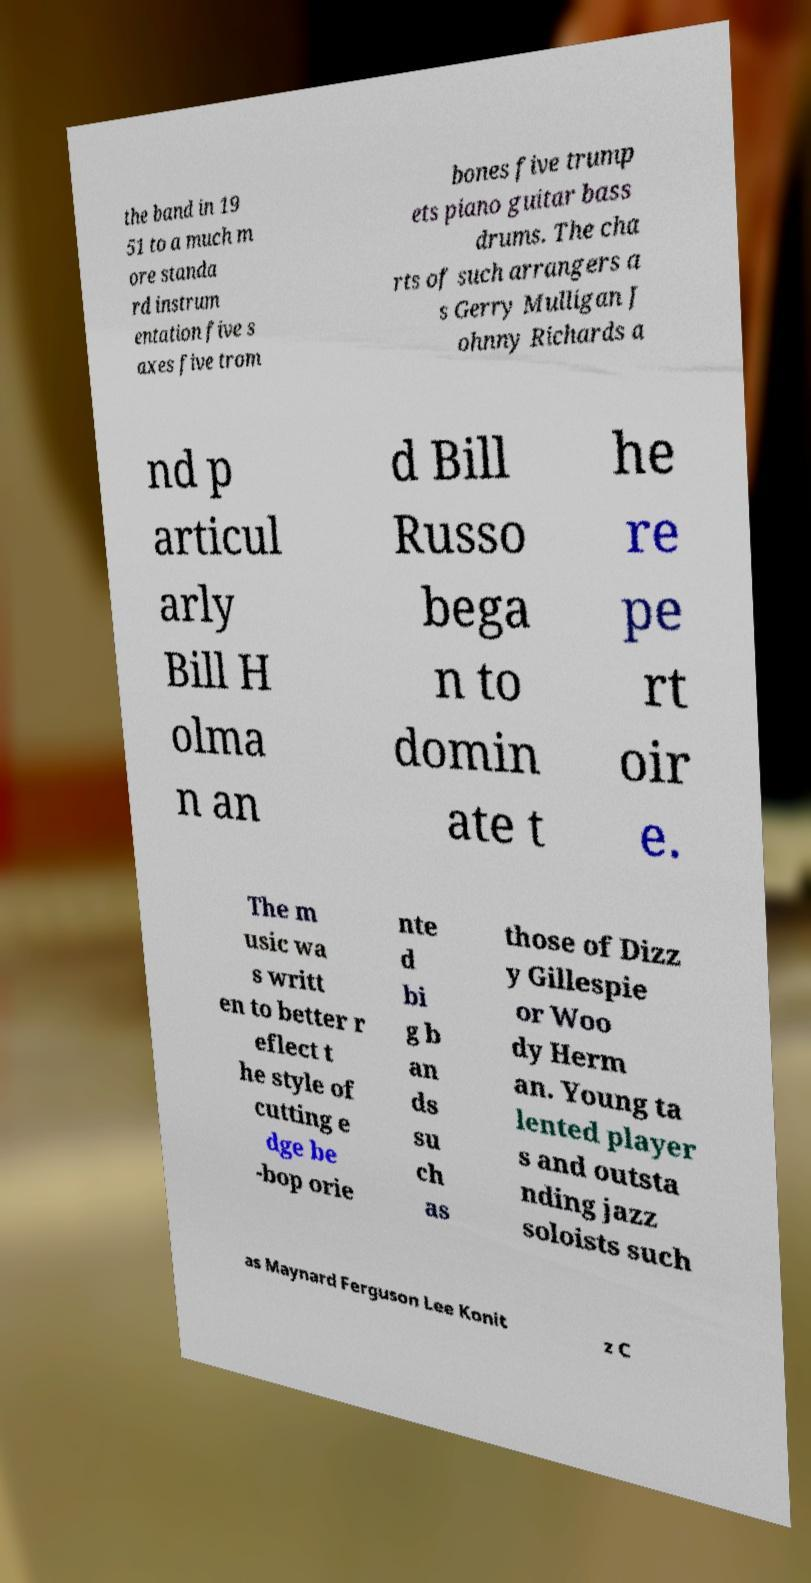For documentation purposes, I need the text within this image transcribed. Could you provide that? the band in 19 51 to a much m ore standa rd instrum entation five s axes five trom bones five trump ets piano guitar bass drums. The cha rts of such arrangers a s Gerry Mulligan J ohnny Richards a nd p articul arly Bill H olma n an d Bill Russo bega n to domin ate t he re pe rt oir e. The m usic wa s writt en to better r eflect t he style of cutting e dge be -bop orie nte d bi g b an ds su ch as those of Dizz y Gillespie or Woo dy Herm an. Young ta lented player s and outsta nding jazz soloists such as Maynard Ferguson Lee Konit z C 